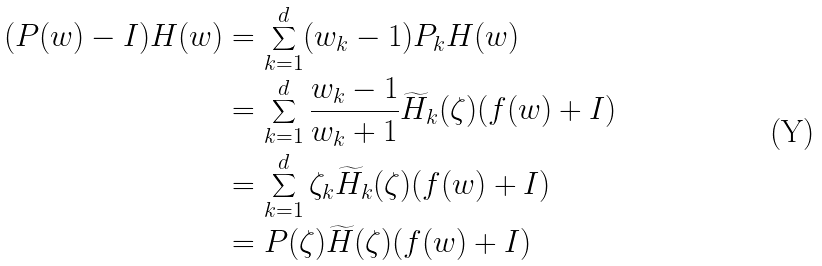Convert formula to latex. <formula><loc_0><loc_0><loc_500><loc_500>( P ( w ) - I ) H ( w ) & = \sum _ { k = 1 } ^ { d } ( w _ { k } - 1 ) P _ { k } H ( w ) \\ & = \sum _ { k = 1 } ^ { d } \frac { w _ { k } - 1 } { w _ { k } + 1 } \widetilde { H } _ { k } ( \zeta ) ( f ( w ) + I ) \\ & = \sum _ { k = 1 } ^ { d } \zeta _ { k } \widetilde { H } _ { k } ( \zeta ) ( f ( w ) + I ) \\ & = P ( \zeta ) \widetilde { H } ( \zeta ) ( f ( w ) + I )</formula> 